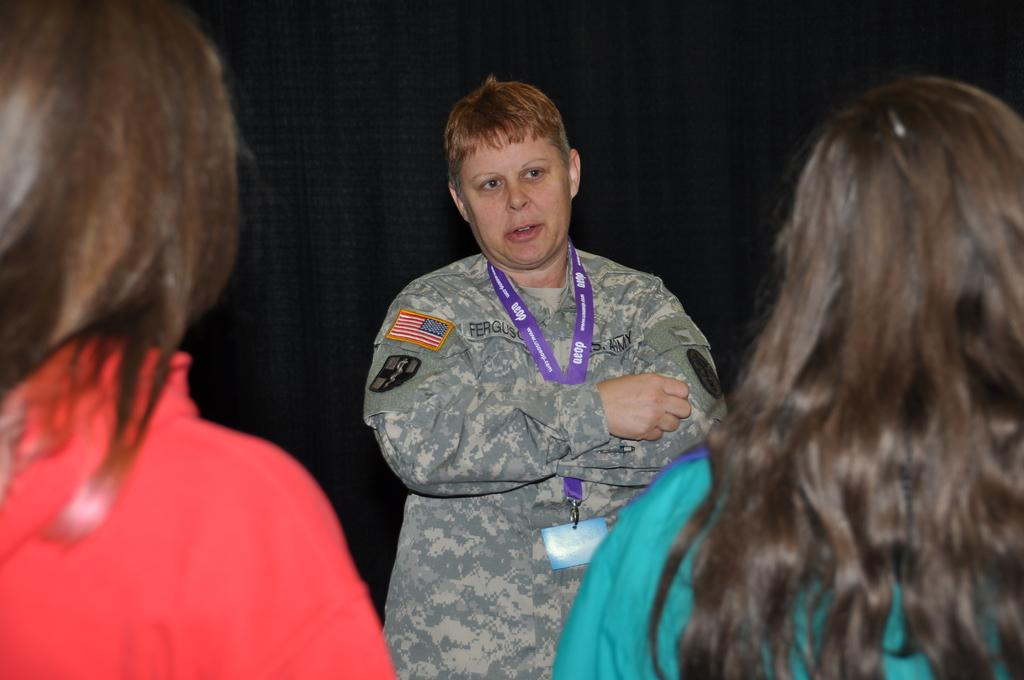How many women are present in the image? There are three women in the image. Can you describe the positioning of the women in the image? One woman is in the background, and two women are in the foreground. What is the background of the image composed of? There is a black surface in the background of the image. What type of plantation can be seen in the background of the image? There is no plantation present in the image; the background is composed of a black surface. What invention is being demonstrated by the women in the image? There is no invention being demonstrated by the women in the image; they are simply positioned in the foreground and background. 